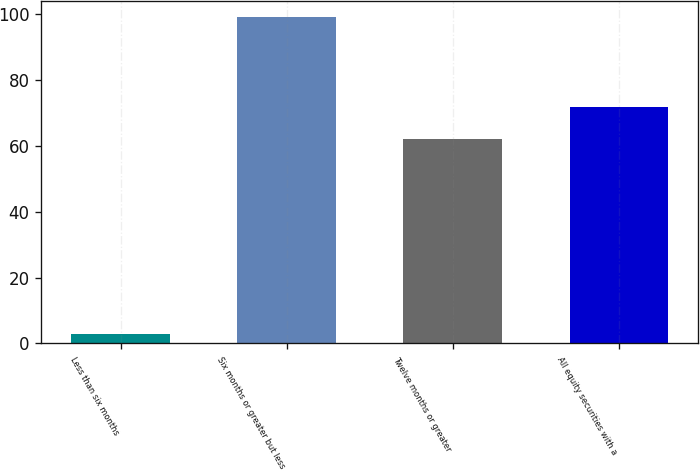Convert chart to OTSL. <chart><loc_0><loc_0><loc_500><loc_500><bar_chart><fcel>Less than six months<fcel>Six months or greater but less<fcel>Twelve months or greater<fcel>All equity securities with a<nl><fcel>3<fcel>99<fcel>62<fcel>71.6<nl></chart> 